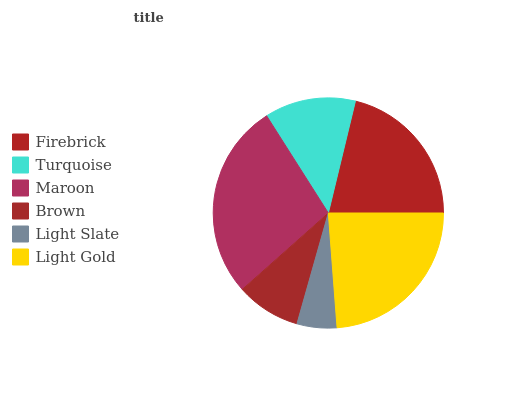Is Light Slate the minimum?
Answer yes or no. Yes. Is Maroon the maximum?
Answer yes or no. Yes. Is Turquoise the minimum?
Answer yes or no. No. Is Turquoise the maximum?
Answer yes or no. No. Is Firebrick greater than Turquoise?
Answer yes or no. Yes. Is Turquoise less than Firebrick?
Answer yes or no. Yes. Is Turquoise greater than Firebrick?
Answer yes or no. No. Is Firebrick less than Turquoise?
Answer yes or no. No. Is Firebrick the high median?
Answer yes or no. Yes. Is Turquoise the low median?
Answer yes or no. Yes. Is Brown the high median?
Answer yes or no. No. Is Brown the low median?
Answer yes or no. No. 